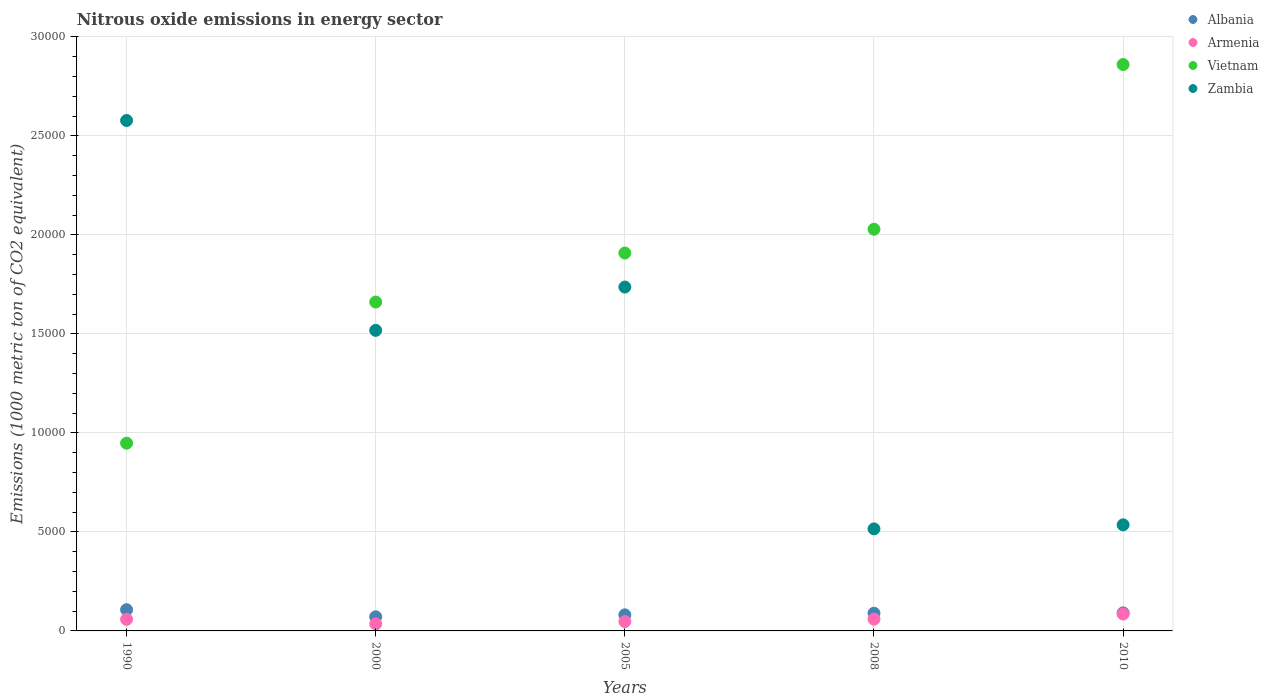How many different coloured dotlines are there?
Your response must be concise. 4. What is the amount of nitrous oxide emitted in Armenia in 2000?
Offer a terse response. 356.1. Across all years, what is the maximum amount of nitrous oxide emitted in Zambia?
Make the answer very short. 2.58e+04. Across all years, what is the minimum amount of nitrous oxide emitted in Vietnam?
Ensure brevity in your answer.  9479.8. What is the total amount of nitrous oxide emitted in Albania in the graph?
Provide a succinct answer. 4401. What is the difference between the amount of nitrous oxide emitted in Zambia in 2000 and that in 2005?
Give a very brief answer. -2187.2. What is the difference between the amount of nitrous oxide emitted in Vietnam in 2005 and the amount of nitrous oxide emitted in Armenia in 2010?
Offer a very short reply. 1.82e+04. What is the average amount of nitrous oxide emitted in Vietnam per year?
Offer a terse response. 1.88e+04. In the year 2000, what is the difference between the amount of nitrous oxide emitted in Zambia and amount of nitrous oxide emitted in Albania?
Your answer should be compact. 1.45e+04. In how many years, is the amount of nitrous oxide emitted in Armenia greater than 7000 1000 metric ton?
Offer a terse response. 0. What is the ratio of the amount of nitrous oxide emitted in Zambia in 2005 to that in 2008?
Offer a terse response. 3.37. Is the amount of nitrous oxide emitted in Zambia in 1990 less than that in 2008?
Give a very brief answer. No. What is the difference between the highest and the second highest amount of nitrous oxide emitted in Armenia?
Provide a short and direct response. 259.9. What is the difference between the highest and the lowest amount of nitrous oxide emitted in Armenia?
Offer a very short reply. 497.3. Is the sum of the amount of nitrous oxide emitted in Albania in 2005 and 2008 greater than the maximum amount of nitrous oxide emitted in Armenia across all years?
Give a very brief answer. Yes. Is it the case that in every year, the sum of the amount of nitrous oxide emitted in Zambia and amount of nitrous oxide emitted in Vietnam  is greater than the amount of nitrous oxide emitted in Armenia?
Provide a short and direct response. Yes. Does the amount of nitrous oxide emitted in Vietnam monotonically increase over the years?
Keep it short and to the point. Yes. Is the amount of nitrous oxide emitted in Zambia strictly less than the amount of nitrous oxide emitted in Albania over the years?
Offer a very short reply. No. What is the difference between two consecutive major ticks on the Y-axis?
Offer a very short reply. 5000. Does the graph contain grids?
Ensure brevity in your answer.  Yes. Where does the legend appear in the graph?
Your answer should be compact. Top right. How many legend labels are there?
Make the answer very short. 4. How are the legend labels stacked?
Keep it short and to the point. Vertical. What is the title of the graph?
Your response must be concise. Nitrous oxide emissions in energy sector. Does "Barbados" appear as one of the legend labels in the graph?
Offer a very short reply. No. What is the label or title of the Y-axis?
Ensure brevity in your answer.  Emissions (1000 metric ton of CO2 equivalent). What is the Emissions (1000 metric ton of CO2 equivalent) in Albania in 1990?
Your answer should be compact. 1071.9. What is the Emissions (1000 metric ton of CO2 equivalent) of Armenia in 1990?
Your answer should be compact. 586.2. What is the Emissions (1000 metric ton of CO2 equivalent) in Vietnam in 1990?
Give a very brief answer. 9479.8. What is the Emissions (1000 metric ton of CO2 equivalent) in Zambia in 1990?
Provide a short and direct response. 2.58e+04. What is the Emissions (1000 metric ton of CO2 equivalent) of Albania in 2000?
Your response must be concise. 712.1. What is the Emissions (1000 metric ton of CO2 equivalent) of Armenia in 2000?
Provide a short and direct response. 356.1. What is the Emissions (1000 metric ton of CO2 equivalent) in Vietnam in 2000?
Offer a very short reply. 1.66e+04. What is the Emissions (1000 metric ton of CO2 equivalent) of Zambia in 2000?
Provide a short and direct response. 1.52e+04. What is the Emissions (1000 metric ton of CO2 equivalent) of Albania in 2005?
Offer a terse response. 812. What is the Emissions (1000 metric ton of CO2 equivalent) of Armenia in 2005?
Make the answer very short. 473.3. What is the Emissions (1000 metric ton of CO2 equivalent) of Vietnam in 2005?
Your answer should be very brief. 1.91e+04. What is the Emissions (1000 metric ton of CO2 equivalent) of Zambia in 2005?
Give a very brief answer. 1.74e+04. What is the Emissions (1000 metric ton of CO2 equivalent) in Albania in 2008?
Your response must be concise. 894. What is the Emissions (1000 metric ton of CO2 equivalent) in Armenia in 2008?
Your response must be concise. 593.5. What is the Emissions (1000 metric ton of CO2 equivalent) of Vietnam in 2008?
Give a very brief answer. 2.03e+04. What is the Emissions (1000 metric ton of CO2 equivalent) of Zambia in 2008?
Offer a terse response. 5152.9. What is the Emissions (1000 metric ton of CO2 equivalent) in Albania in 2010?
Provide a succinct answer. 911. What is the Emissions (1000 metric ton of CO2 equivalent) of Armenia in 2010?
Your answer should be compact. 853.4. What is the Emissions (1000 metric ton of CO2 equivalent) in Vietnam in 2010?
Make the answer very short. 2.86e+04. What is the Emissions (1000 metric ton of CO2 equivalent) in Zambia in 2010?
Provide a short and direct response. 5357.6. Across all years, what is the maximum Emissions (1000 metric ton of CO2 equivalent) in Albania?
Your answer should be compact. 1071.9. Across all years, what is the maximum Emissions (1000 metric ton of CO2 equivalent) in Armenia?
Provide a succinct answer. 853.4. Across all years, what is the maximum Emissions (1000 metric ton of CO2 equivalent) of Vietnam?
Your answer should be very brief. 2.86e+04. Across all years, what is the maximum Emissions (1000 metric ton of CO2 equivalent) of Zambia?
Offer a very short reply. 2.58e+04. Across all years, what is the minimum Emissions (1000 metric ton of CO2 equivalent) of Albania?
Your response must be concise. 712.1. Across all years, what is the minimum Emissions (1000 metric ton of CO2 equivalent) in Armenia?
Provide a succinct answer. 356.1. Across all years, what is the minimum Emissions (1000 metric ton of CO2 equivalent) of Vietnam?
Your response must be concise. 9479.8. Across all years, what is the minimum Emissions (1000 metric ton of CO2 equivalent) of Zambia?
Offer a terse response. 5152.9. What is the total Emissions (1000 metric ton of CO2 equivalent) of Albania in the graph?
Provide a succinct answer. 4401. What is the total Emissions (1000 metric ton of CO2 equivalent) in Armenia in the graph?
Provide a short and direct response. 2862.5. What is the total Emissions (1000 metric ton of CO2 equivalent) in Vietnam in the graph?
Offer a terse response. 9.40e+04. What is the total Emissions (1000 metric ton of CO2 equivalent) of Zambia in the graph?
Provide a succinct answer. 6.88e+04. What is the difference between the Emissions (1000 metric ton of CO2 equivalent) in Albania in 1990 and that in 2000?
Ensure brevity in your answer.  359.8. What is the difference between the Emissions (1000 metric ton of CO2 equivalent) of Armenia in 1990 and that in 2000?
Your response must be concise. 230.1. What is the difference between the Emissions (1000 metric ton of CO2 equivalent) of Vietnam in 1990 and that in 2000?
Keep it short and to the point. -7126.8. What is the difference between the Emissions (1000 metric ton of CO2 equivalent) in Zambia in 1990 and that in 2000?
Provide a short and direct response. 1.06e+04. What is the difference between the Emissions (1000 metric ton of CO2 equivalent) in Albania in 1990 and that in 2005?
Offer a very short reply. 259.9. What is the difference between the Emissions (1000 metric ton of CO2 equivalent) of Armenia in 1990 and that in 2005?
Provide a succinct answer. 112.9. What is the difference between the Emissions (1000 metric ton of CO2 equivalent) in Vietnam in 1990 and that in 2005?
Keep it short and to the point. -9601.2. What is the difference between the Emissions (1000 metric ton of CO2 equivalent) of Zambia in 1990 and that in 2005?
Keep it short and to the point. 8411.4. What is the difference between the Emissions (1000 metric ton of CO2 equivalent) of Albania in 1990 and that in 2008?
Provide a short and direct response. 177.9. What is the difference between the Emissions (1000 metric ton of CO2 equivalent) in Vietnam in 1990 and that in 2008?
Your answer should be very brief. -1.08e+04. What is the difference between the Emissions (1000 metric ton of CO2 equivalent) of Zambia in 1990 and that in 2008?
Your answer should be compact. 2.06e+04. What is the difference between the Emissions (1000 metric ton of CO2 equivalent) in Albania in 1990 and that in 2010?
Keep it short and to the point. 160.9. What is the difference between the Emissions (1000 metric ton of CO2 equivalent) of Armenia in 1990 and that in 2010?
Offer a very short reply. -267.2. What is the difference between the Emissions (1000 metric ton of CO2 equivalent) in Vietnam in 1990 and that in 2010?
Offer a very short reply. -1.91e+04. What is the difference between the Emissions (1000 metric ton of CO2 equivalent) in Zambia in 1990 and that in 2010?
Your answer should be very brief. 2.04e+04. What is the difference between the Emissions (1000 metric ton of CO2 equivalent) of Albania in 2000 and that in 2005?
Provide a short and direct response. -99.9. What is the difference between the Emissions (1000 metric ton of CO2 equivalent) of Armenia in 2000 and that in 2005?
Your response must be concise. -117.2. What is the difference between the Emissions (1000 metric ton of CO2 equivalent) in Vietnam in 2000 and that in 2005?
Offer a terse response. -2474.4. What is the difference between the Emissions (1000 metric ton of CO2 equivalent) of Zambia in 2000 and that in 2005?
Make the answer very short. -2187.2. What is the difference between the Emissions (1000 metric ton of CO2 equivalent) in Albania in 2000 and that in 2008?
Ensure brevity in your answer.  -181.9. What is the difference between the Emissions (1000 metric ton of CO2 equivalent) of Armenia in 2000 and that in 2008?
Offer a very short reply. -237.4. What is the difference between the Emissions (1000 metric ton of CO2 equivalent) of Vietnam in 2000 and that in 2008?
Your response must be concise. -3676.6. What is the difference between the Emissions (1000 metric ton of CO2 equivalent) in Zambia in 2000 and that in 2008?
Offer a terse response. 1.00e+04. What is the difference between the Emissions (1000 metric ton of CO2 equivalent) of Albania in 2000 and that in 2010?
Provide a succinct answer. -198.9. What is the difference between the Emissions (1000 metric ton of CO2 equivalent) in Armenia in 2000 and that in 2010?
Offer a terse response. -497.3. What is the difference between the Emissions (1000 metric ton of CO2 equivalent) in Vietnam in 2000 and that in 2010?
Make the answer very short. -1.20e+04. What is the difference between the Emissions (1000 metric ton of CO2 equivalent) in Zambia in 2000 and that in 2010?
Offer a terse response. 9818.5. What is the difference between the Emissions (1000 metric ton of CO2 equivalent) in Albania in 2005 and that in 2008?
Your response must be concise. -82. What is the difference between the Emissions (1000 metric ton of CO2 equivalent) of Armenia in 2005 and that in 2008?
Provide a succinct answer. -120.2. What is the difference between the Emissions (1000 metric ton of CO2 equivalent) in Vietnam in 2005 and that in 2008?
Offer a terse response. -1202.2. What is the difference between the Emissions (1000 metric ton of CO2 equivalent) of Zambia in 2005 and that in 2008?
Keep it short and to the point. 1.22e+04. What is the difference between the Emissions (1000 metric ton of CO2 equivalent) in Albania in 2005 and that in 2010?
Provide a short and direct response. -99. What is the difference between the Emissions (1000 metric ton of CO2 equivalent) in Armenia in 2005 and that in 2010?
Provide a short and direct response. -380.1. What is the difference between the Emissions (1000 metric ton of CO2 equivalent) of Vietnam in 2005 and that in 2010?
Give a very brief answer. -9517.8. What is the difference between the Emissions (1000 metric ton of CO2 equivalent) in Zambia in 2005 and that in 2010?
Your response must be concise. 1.20e+04. What is the difference between the Emissions (1000 metric ton of CO2 equivalent) of Armenia in 2008 and that in 2010?
Ensure brevity in your answer.  -259.9. What is the difference between the Emissions (1000 metric ton of CO2 equivalent) of Vietnam in 2008 and that in 2010?
Your response must be concise. -8315.6. What is the difference between the Emissions (1000 metric ton of CO2 equivalent) of Zambia in 2008 and that in 2010?
Offer a terse response. -204.7. What is the difference between the Emissions (1000 metric ton of CO2 equivalent) in Albania in 1990 and the Emissions (1000 metric ton of CO2 equivalent) in Armenia in 2000?
Provide a short and direct response. 715.8. What is the difference between the Emissions (1000 metric ton of CO2 equivalent) in Albania in 1990 and the Emissions (1000 metric ton of CO2 equivalent) in Vietnam in 2000?
Ensure brevity in your answer.  -1.55e+04. What is the difference between the Emissions (1000 metric ton of CO2 equivalent) of Albania in 1990 and the Emissions (1000 metric ton of CO2 equivalent) of Zambia in 2000?
Your response must be concise. -1.41e+04. What is the difference between the Emissions (1000 metric ton of CO2 equivalent) in Armenia in 1990 and the Emissions (1000 metric ton of CO2 equivalent) in Vietnam in 2000?
Make the answer very short. -1.60e+04. What is the difference between the Emissions (1000 metric ton of CO2 equivalent) in Armenia in 1990 and the Emissions (1000 metric ton of CO2 equivalent) in Zambia in 2000?
Your answer should be compact. -1.46e+04. What is the difference between the Emissions (1000 metric ton of CO2 equivalent) of Vietnam in 1990 and the Emissions (1000 metric ton of CO2 equivalent) of Zambia in 2000?
Offer a terse response. -5696.3. What is the difference between the Emissions (1000 metric ton of CO2 equivalent) in Albania in 1990 and the Emissions (1000 metric ton of CO2 equivalent) in Armenia in 2005?
Offer a very short reply. 598.6. What is the difference between the Emissions (1000 metric ton of CO2 equivalent) in Albania in 1990 and the Emissions (1000 metric ton of CO2 equivalent) in Vietnam in 2005?
Keep it short and to the point. -1.80e+04. What is the difference between the Emissions (1000 metric ton of CO2 equivalent) in Albania in 1990 and the Emissions (1000 metric ton of CO2 equivalent) in Zambia in 2005?
Ensure brevity in your answer.  -1.63e+04. What is the difference between the Emissions (1000 metric ton of CO2 equivalent) in Armenia in 1990 and the Emissions (1000 metric ton of CO2 equivalent) in Vietnam in 2005?
Provide a succinct answer. -1.85e+04. What is the difference between the Emissions (1000 metric ton of CO2 equivalent) in Armenia in 1990 and the Emissions (1000 metric ton of CO2 equivalent) in Zambia in 2005?
Ensure brevity in your answer.  -1.68e+04. What is the difference between the Emissions (1000 metric ton of CO2 equivalent) of Vietnam in 1990 and the Emissions (1000 metric ton of CO2 equivalent) of Zambia in 2005?
Your answer should be compact. -7883.5. What is the difference between the Emissions (1000 metric ton of CO2 equivalent) of Albania in 1990 and the Emissions (1000 metric ton of CO2 equivalent) of Armenia in 2008?
Your answer should be compact. 478.4. What is the difference between the Emissions (1000 metric ton of CO2 equivalent) in Albania in 1990 and the Emissions (1000 metric ton of CO2 equivalent) in Vietnam in 2008?
Offer a terse response. -1.92e+04. What is the difference between the Emissions (1000 metric ton of CO2 equivalent) of Albania in 1990 and the Emissions (1000 metric ton of CO2 equivalent) of Zambia in 2008?
Make the answer very short. -4081. What is the difference between the Emissions (1000 metric ton of CO2 equivalent) in Armenia in 1990 and the Emissions (1000 metric ton of CO2 equivalent) in Vietnam in 2008?
Offer a terse response. -1.97e+04. What is the difference between the Emissions (1000 metric ton of CO2 equivalent) in Armenia in 1990 and the Emissions (1000 metric ton of CO2 equivalent) in Zambia in 2008?
Offer a very short reply. -4566.7. What is the difference between the Emissions (1000 metric ton of CO2 equivalent) of Vietnam in 1990 and the Emissions (1000 metric ton of CO2 equivalent) of Zambia in 2008?
Keep it short and to the point. 4326.9. What is the difference between the Emissions (1000 metric ton of CO2 equivalent) of Albania in 1990 and the Emissions (1000 metric ton of CO2 equivalent) of Armenia in 2010?
Provide a succinct answer. 218.5. What is the difference between the Emissions (1000 metric ton of CO2 equivalent) of Albania in 1990 and the Emissions (1000 metric ton of CO2 equivalent) of Vietnam in 2010?
Your response must be concise. -2.75e+04. What is the difference between the Emissions (1000 metric ton of CO2 equivalent) in Albania in 1990 and the Emissions (1000 metric ton of CO2 equivalent) in Zambia in 2010?
Ensure brevity in your answer.  -4285.7. What is the difference between the Emissions (1000 metric ton of CO2 equivalent) of Armenia in 1990 and the Emissions (1000 metric ton of CO2 equivalent) of Vietnam in 2010?
Your answer should be very brief. -2.80e+04. What is the difference between the Emissions (1000 metric ton of CO2 equivalent) in Armenia in 1990 and the Emissions (1000 metric ton of CO2 equivalent) in Zambia in 2010?
Make the answer very short. -4771.4. What is the difference between the Emissions (1000 metric ton of CO2 equivalent) of Vietnam in 1990 and the Emissions (1000 metric ton of CO2 equivalent) of Zambia in 2010?
Your answer should be very brief. 4122.2. What is the difference between the Emissions (1000 metric ton of CO2 equivalent) of Albania in 2000 and the Emissions (1000 metric ton of CO2 equivalent) of Armenia in 2005?
Keep it short and to the point. 238.8. What is the difference between the Emissions (1000 metric ton of CO2 equivalent) in Albania in 2000 and the Emissions (1000 metric ton of CO2 equivalent) in Vietnam in 2005?
Ensure brevity in your answer.  -1.84e+04. What is the difference between the Emissions (1000 metric ton of CO2 equivalent) in Albania in 2000 and the Emissions (1000 metric ton of CO2 equivalent) in Zambia in 2005?
Offer a very short reply. -1.67e+04. What is the difference between the Emissions (1000 metric ton of CO2 equivalent) in Armenia in 2000 and the Emissions (1000 metric ton of CO2 equivalent) in Vietnam in 2005?
Make the answer very short. -1.87e+04. What is the difference between the Emissions (1000 metric ton of CO2 equivalent) in Armenia in 2000 and the Emissions (1000 metric ton of CO2 equivalent) in Zambia in 2005?
Your answer should be compact. -1.70e+04. What is the difference between the Emissions (1000 metric ton of CO2 equivalent) in Vietnam in 2000 and the Emissions (1000 metric ton of CO2 equivalent) in Zambia in 2005?
Provide a succinct answer. -756.7. What is the difference between the Emissions (1000 metric ton of CO2 equivalent) of Albania in 2000 and the Emissions (1000 metric ton of CO2 equivalent) of Armenia in 2008?
Provide a short and direct response. 118.6. What is the difference between the Emissions (1000 metric ton of CO2 equivalent) of Albania in 2000 and the Emissions (1000 metric ton of CO2 equivalent) of Vietnam in 2008?
Your answer should be very brief. -1.96e+04. What is the difference between the Emissions (1000 metric ton of CO2 equivalent) in Albania in 2000 and the Emissions (1000 metric ton of CO2 equivalent) in Zambia in 2008?
Make the answer very short. -4440.8. What is the difference between the Emissions (1000 metric ton of CO2 equivalent) in Armenia in 2000 and the Emissions (1000 metric ton of CO2 equivalent) in Vietnam in 2008?
Offer a very short reply. -1.99e+04. What is the difference between the Emissions (1000 metric ton of CO2 equivalent) of Armenia in 2000 and the Emissions (1000 metric ton of CO2 equivalent) of Zambia in 2008?
Your answer should be compact. -4796.8. What is the difference between the Emissions (1000 metric ton of CO2 equivalent) of Vietnam in 2000 and the Emissions (1000 metric ton of CO2 equivalent) of Zambia in 2008?
Give a very brief answer. 1.15e+04. What is the difference between the Emissions (1000 metric ton of CO2 equivalent) in Albania in 2000 and the Emissions (1000 metric ton of CO2 equivalent) in Armenia in 2010?
Offer a terse response. -141.3. What is the difference between the Emissions (1000 metric ton of CO2 equivalent) of Albania in 2000 and the Emissions (1000 metric ton of CO2 equivalent) of Vietnam in 2010?
Give a very brief answer. -2.79e+04. What is the difference between the Emissions (1000 metric ton of CO2 equivalent) in Albania in 2000 and the Emissions (1000 metric ton of CO2 equivalent) in Zambia in 2010?
Your response must be concise. -4645.5. What is the difference between the Emissions (1000 metric ton of CO2 equivalent) in Armenia in 2000 and the Emissions (1000 metric ton of CO2 equivalent) in Vietnam in 2010?
Offer a very short reply. -2.82e+04. What is the difference between the Emissions (1000 metric ton of CO2 equivalent) in Armenia in 2000 and the Emissions (1000 metric ton of CO2 equivalent) in Zambia in 2010?
Make the answer very short. -5001.5. What is the difference between the Emissions (1000 metric ton of CO2 equivalent) in Vietnam in 2000 and the Emissions (1000 metric ton of CO2 equivalent) in Zambia in 2010?
Provide a short and direct response. 1.12e+04. What is the difference between the Emissions (1000 metric ton of CO2 equivalent) in Albania in 2005 and the Emissions (1000 metric ton of CO2 equivalent) in Armenia in 2008?
Give a very brief answer. 218.5. What is the difference between the Emissions (1000 metric ton of CO2 equivalent) in Albania in 2005 and the Emissions (1000 metric ton of CO2 equivalent) in Vietnam in 2008?
Your answer should be compact. -1.95e+04. What is the difference between the Emissions (1000 metric ton of CO2 equivalent) in Albania in 2005 and the Emissions (1000 metric ton of CO2 equivalent) in Zambia in 2008?
Your answer should be very brief. -4340.9. What is the difference between the Emissions (1000 metric ton of CO2 equivalent) of Armenia in 2005 and the Emissions (1000 metric ton of CO2 equivalent) of Vietnam in 2008?
Your answer should be very brief. -1.98e+04. What is the difference between the Emissions (1000 metric ton of CO2 equivalent) of Armenia in 2005 and the Emissions (1000 metric ton of CO2 equivalent) of Zambia in 2008?
Your answer should be compact. -4679.6. What is the difference between the Emissions (1000 metric ton of CO2 equivalent) of Vietnam in 2005 and the Emissions (1000 metric ton of CO2 equivalent) of Zambia in 2008?
Make the answer very short. 1.39e+04. What is the difference between the Emissions (1000 metric ton of CO2 equivalent) of Albania in 2005 and the Emissions (1000 metric ton of CO2 equivalent) of Armenia in 2010?
Offer a very short reply. -41.4. What is the difference between the Emissions (1000 metric ton of CO2 equivalent) in Albania in 2005 and the Emissions (1000 metric ton of CO2 equivalent) in Vietnam in 2010?
Provide a succinct answer. -2.78e+04. What is the difference between the Emissions (1000 metric ton of CO2 equivalent) in Albania in 2005 and the Emissions (1000 metric ton of CO2 equivalent) in Zambia in 2010?
Offer a very short reply. -4545.6. What is the difference between the Emissions (1000 metric ton of CO2 equivalent) in Armenia in 2005 and the Emissions (1000 metric ton of CO2 equivalent) in Vietnam in 2010?
Keep it short and to the point. -2.81e+04. What is the difference between the Emissions (1000 metric ton of CO2 equivalent) in Armenia in 2005 and the Emissions (1000 metric ton of CO2 equivalent) in Zambia in 2010?
Keep it short and to the point. -4884.3. What is the difference between the Emissions (1000 metric ton of CO2 equivalent) in Vietnam in 2005 and the Emissions (1000 metric ton of CO2 equivalent) in Zambia in 2010?
Your answer should be very brief. 1.37e+04. What is the difference between the Emissions (1000 metric ton of CO2 equivalent) of Albania in 2008 and the Emissions (1000 metric ton of CO2 equivalent) of Armenia in 2010?
Keep it short and to the point. 40.6. What is the difference between the Emissions (1000 metric ton of CO2 equivalent) of Albania in 2008 and the Emissions (1000 metric ton of CO2 equivalent) of Vietnam in 2010?
Give a very brief answer. -2.77e+04. What is the difference between the Emissions (1000 metric ton of CO2 equivalent) of Albania in 2008 and the Emissions (1000 metric ton of CO2 equivalent) of Zambia in 2010?
Offer a terse response. -4463.6. What is the difference between the Emissions (1000 metric ton of CO2 equivalent) in Armenia in 2008 and the Emissions (1000 metric ton of CO2 equivalent) in Vietnam in 2010?
Offer a terse response. -2.80e+04. What is the difference between the Emissions (1000 metric ton of CO2 equivalent) of Armenia in 2008 and the Emissions (1000 metric ton of CO2 equivalent) of Zambia in 2010?
Provide a succinct answer. -4764.1. What is the difference between the Emissions (1000 metric ton of CO2 equivalent) of Vietnam in 2008 and the Emissions (1000 metric ton of CO2 equivalent) of Zambia in 2010?
Offer a very short reply. 1.49e+04. What is the average Emissions (1000 metric ton of CO2 equivalent) of Albania per year?
Provide a short and direct response. 880.2. What is the average Emissions (1000 metric ton of CO2 equivalent) of Armenia per year?
Your answer should be compact. 572.5. What is the average Emissions (1000 metric ton of CO2 equivalent) of Vietnam per year?
Your answer should be compact. 1.88e+04. What is the average Emissions (1000 metric ton of CO2 equivalent) of Zambia per year?
Offer a very short reply. 1.38e+04. In the year 1990, what is the difference between the Emissions (1000 metric ton of CO2 equivalent) in Albania and Emissions (1000 metric ton of CO2 equivalent) in Armenia?
Your response must be concise. 485.7. In the year 1990, what is the difference between the Emissions (1000 metric ton of CO2 equivalent) in Albania and Emissions (1000 metric ton of CO2 equivalent) in Vietnam?
Provide a succinct answer. -8407.9. In the year 1990, what is the difference between the Emissions (1000 metric ton of CO2 equivalent) of Albania and Emissions (1000 metric ton of CO2 equivalent) of Zambia?
Offer a terse response. -2.47e+04. In the year 1990, what is the difference between the Emissions (1000 metric ton of CO2 equivalent) of Armenia and Emissions (1000 metric ton of CO2 equivalent) of Vietnam?
Provide a short and direct response. -8893.6. In the year 1990, what is the difference between the Emissions (1000 metric ton of CO2 equivalent) of Armenia and Emissions (1000 metric ton of CO2 equivalent) of Zambia?
Provide a short and direct response. -2.52e+04. In the year 1990, what is the difference between the Emissions (1000 metric ton of CO2 equivalent) of Vietnam and Emissions (1000 metric ton of CO2 equivalent) of Zambia?
Provide a short and direct response. -1.63e+04. In the year 2000, what is the difference between the Emissions (1000 metric ton of CO2 equivalent) of Albania and Emissions (1000 metric ton of CO2 equivalent) of Armenia?
Make the answer very short. 356. In the year 2000, what is the difference between the Emissions (1000 metric ton of CO2 equivalent) in Albania and Emissions (1000 metric ton of CO2 equivalent) in Vietnam?
Keep it short and to the point. -1.59e+04. In the year 2000, what is the difference between the Emissions (1000 metric ton of CO2 equivalent) of Albania and Emissions (1000 metric ton of CO2 equivalent) of Zambia?
Provide a short and direct response. -1.45e+04. In the year 2000, what is the difference between the Emissions (1000 metric ton of CO2 equivalent) of Armenia and Emissions (1000 metric ton of CO2 equivalent) of Vietnam?
Your answer should be compact. -1.63e+04. In the year 2000, what is the difference between the Emissions (1000 metric ton of CO2 equivalent) of Armenia and Emissions (1000 metric ton of CO2 equivalent) of Zambia?
Make the answer very short. -1.48e+04. In the year 2000, what is the difference between the Emissions (1000 metric ton of CO2 equivalent) of Vietnam and Emissions (1000 metric ton of CO2 equivalent) of Zambia?
Your response must be concise. 1430.5. In the year 2005, what is the difference between the Emissions (1000 metric ton of CO2 equivalent) in Albania and Emissions (1000 metric ton of CO2 equivalent) in Armenia?
Provide a short and direct response. 338.7. In the year 2005, what is the difference between the Emissions (1000 metric ton of CO2 equivalent) in Albania and Emissions (1000 metric ton of CO2 equivalent) in Vietnam?
Your answer should be compact. -1.83e+04. In the year 2005, what is the difference between the Emissions (1000 metric ton of CO2 equivalent) of Albania and Emissions (1000 metric ton of CO2 equivalent) of Zambia?
Give a very brief answer. -1.66e+04. In the year 2005, what is the difference between the Emissions (1000 metric ton of CO2 equivalent) in Armenia and Emissions (1000 metric ton of CO2 equivalent) in Vietnam?
Provide a succinct answer. -1.86e+04. In the year 2005, what is the difference between the Emissions (1000 metric ton of CO2 equivalent) of Armenia and Emissions (1000 metric ton of CO2 equivalent) of Zambia?
Your answer should be very brief. -1.69e+04. In the year 2005, what is the difference between the Emissions (1000 metric ton of CO2 equivalent) of Vietnam and Emissions (1000 metric ton of CO2 equivalent) of Zambia?
Keep it short and to the point. 1717.7. In the year 2008, what is the difference between the Emissions (1000 metric ton of CO2 equivalent) of Albania and Emissions (1000 metric ton of CO2 equivalent) of Armenia?
Your response must be concise. 300.5. In the year 2008, what is the difference between the Emissions (1000 metric ton of CO2 equivalent) in Albania and Emissions (1000 metric ton of CO2 equivalent) in Vietnam?
Your answer should be compact. -1.94e+04. In the year 2008, what is the difference between the Emissions (1000 metric ton of CO2 equivalent) of Albania and Emissions (1000 metric ton of CO2 equivalent) of Zambia?
Offer a very short reply. -4258.9. In the year 2008, what is the difference between the Emissions (1000 metric ton of CO2 equivalent) of Armenia and Emissions (1000 metric ton of CO2 equivalent) of Vietnam?
Your response must be concise. -1.97e+04. In the year 2008, what is the difference between the Emissions (1000 metric ton of CO2 equivalent) in Armenia and Emissions (1000 metric ton of CO2 equivalent) in Zambia?
Offer a terse response. -4559.4. In the year 2008, what is the difference between the Emissions (1000 metric ton of CO2 equivalent) in Vietnam and Emissions (1000 metric ton of CO2 equivalent) in Zambia?
Offer a very short reply. 1.51e+04. In the year 2010, what is the difference between the Emissions (1000 metric ton of CO2 equivalent) in Albania and Emissions (1000 metric ton of CO2 equivalent) in Armenia?
Provide a short and direct response. 57.6. In the year 2010, what is the difference between the Emissions (1000 metric ton of CO2 equivalent) in Albania and Emissions (1000 metric ton of CO2 equivalent) in Vietnam?
Keep it short and to the point. -2.77e+04. In the year 2010, what is the difference between the Emissions (1000 metric ton of CO2 equivalent) in Albania and Emissions (1000 metric ton of CO2 equivalent) in Zambia?
Ensure brevity in your answer.  -4446.6. In the year 2010, what is the difference between the Emissions (1000 metric ton of CO2 equivalent) in Armenia and Emissions (1000 metric ton of CO2 equivalent) in Vietnam?
Give a very brief answer. -2.77e+04. In the year 2010, what is the difference between the Emissions (1000 metric ton of CO2 equivalent) of Armenia and Emissions (1000 metric ton of CO2 equivalent) of Zambia?
Make the answer very short. -4504.2. In the year 2010, what is the difference between the Emissions (1000 metric ton of CO2 equivalent) in Vietnam and Emissions (1000 metric ton of CO2 equivalent) in Zambia?
Your response must be concise. 2.32e+04. What is the ratio of the Emissions (1000 metric ton of CO2 equivalent) of Albania in 1990 to that in 2000?
Make the answer very short. 1.51. What is the ratio of the Emissions (1000 metric ton of CO2 equivalent) of Armenia in 1990 to that in 2000?
Keep it short and to the point. 1.65. What is the ratio of the Emissions (1000 metric ton of CO2 equivalent) in Vietnam in 1990 to that in 2000?
Keep it short and to the point. 0.57. What is the ratio of the Emissions (1000 metric ton of CO2 equivalent) of Zambia in 1990 to that in 2000?
Keep it short and to the point. 1.7. What is the ratio of the Emissions (1000 metric ton of CO2 equivalent) in Albania in 1990 to that in 2005?
Make the answer very short. 1.32. What is the ratio of the Emissions (1000 metric ton of CO2 equivalent) of Armenia in 1990 to that in 2005?
Provide a short and direct response. 1.24. What is the ratio of the Emissions (1000 metric ton of CO2 equivalent) of Vietnam in 1990 to that in 2005?
Your answer should be compact. 0.5. What is the ratio of the Emissions (1000 metric ton of CO2 equivalent) of Zambia in 1990 to that in 2005?
Your answer should be very brief. 1.48. What is the ratio of the Emissions (1000 metric ton of CO2 equivalent) of Albania in 1990 to that in 2008?
Provide a succinct answer. 1.2. What is the ratio of the Emissions (1000 metric ton of CO2 equivalent) in Armenia in 1990 to that in 2008?
Make the answer very short. 0.99. What is the ratio of the Emissions (1000 metric ton of CO2 equivalent) in Vietnam in 1990 to that in 2008?
Keep it short and to the point. 0.47. What is the ratio of the Emissions (1000 metric ton of CO2 equivalent) of Zambia in 1990 to that in 2008?
Keep it short and to the point. 5. What is the ratio of the Emissions (1000 metric ton of CO2 equivalent) in Albania in 1990 to that in 2010?
Provide a succinct answer. 1.18. What is the ratio of the Emissions (1000 metric ton of CO2 equivalent) in Armenia in 1990 to that in 2010?
Your response must be concise. 0.69. What is the ratio of the Emissions (1000 metric ton of CO2 equivalent) in Vietnam in 1990 to that in 2010?
Offer a terse response. 0.33. What is the ratio of the Emissions (1000 metric ton of CO2 equivalent) of Zambia in 1990 to that in 2010?
Offer a terse response. 4.81. What is the ratio of the Emissions (1000 metric ton of CO2 equivalent) in Albania in 2000 to that in 2005?
Your answer should be compact. 0.88. What is the ratio of the Emissions (1000 metric ton of CO2 equivalent) of Armenia in 2000 to that in 2005?
Give a very brief answer. 0.75. What is the ratio of the Emissions (1000 metric ton of CO2 equivalent) in Vietnam in 2000 to that in 2005?
Ensure brevity in your answer.  0.87. What is the ratio of the Emissions (1000 metric ton of CO2 equivalent) of Zambia in 2000 to that in 2005?
Give a very brief answer. 0.87. What is the ratio of the Emissions (1000 metric ton of CO2 equivalent) of Albania in 2000 to that in 2008?
Your answer should be compact. 0.8. What is the ratio of the Emissions (1000 metric ton of CO2 equivalent) of Armenia in 2000 to that in 2008?
Provide a short and direct response. 0.6. What is the ratio of the Emissions (1000 metric ton of CO2 equivalent) in Vietnam in 2000 to that in 2008?
Give a very brief answer. 0.82. What is the ratio of the Emissions (1000 metric ton of CO2 equivalent) in Zambia in 2000 to that in 2008?
Your response must be concise. 2.95. What is the ratio of the Emissions (1000 metric ton of CO2 equivalent) in Albania in 2000 to that in 2010?
Offer a very short reply. 0.78. What is the ratio of the Emissions (1000 metric ton of CO2 equivalent) of Armenia in 2000 to that in 2010?
Provide a succinct answer. 0.42. What is the ratio of the Emissions (1000 metric ton of CO2 equivalent) of Vietnam in 2000 to that in 2010?
Give a very brief answer. 0.58. What is the ratio of the Emissions (1000 metric ton of CO2 equivalent) in Zambia in 2000 to that in 2010?
Provide a short and direct response. 2.83. What is the ratio of the Emissions (1000 metric ton of CO2 equivalent) in Albania in 2005 to that in 2008?
Provide a succinct answer. 0.91. What is the ratio of the Emissions (1000 metric ton of CO2 equivalent) of Armenia in 2005 to that in 2008?
Provide a succinct answer. 0.8. What is the ratio of the Emissions (1000 metric ton of CO2 equivalent) of Vietnam in 2005 to that in 2008?
Keep it short and to the point. 0.94. What is the ratio of the Emissions (1000 metric ton of CO2 equivalent) in Zambia in 2005 to that in 2008?
Keep it short and to the point. 3.37. What is the ratio of the Emissions (1000 metric ton of CO2 equivalent) in Albania in 2005 to that in 2010?
Offer a very short reply. 0.89. What is the ratio of the Emissions (1000 metric ton of CO2 equivalent) of Armenia in 2005 to that in 2010?
Ensure brevity in your answer.  0.55. What is the ratio of the Emissions (1000 metric ton of CO2 equivalent) in Vietnam in 2005 to that in 2010?
Ensure brevity in your answer.  0.67. What is the ratio of the Emissions (1000 metric ton of CO2 equivalent) of Zambia in 2005 to that in 2010?
Your response must be concise. 3.24. What is the ratio of the Emissions (1000 metric ton of CO2 equivalent) of Albania in 2008 to that in 2010?
Provide a succinct answer. 0.98. What is the ratio of the Emissions (1000 metric ton of CO2 equivalent) of Armenia in 2008 to that in 2010?
Your answer should be very brief. 0.7. What is the ratio of the Emissions (1000 metric ton of CO2 equivalent) in Vietnam in 2008 to that in 2010?
Give a very brief answer. 0.71. What is the ratio of the Emissions (1000 metric ton of CO2 equivalent) in Zambia in 2008 to that in 2010?
Your answer should be compact. 0.96. What is the difference between the highest and the second highest Emissions (1000 metric ton of CO2 equivalent) of Albania?
Your answer should be very brief. 160.9. What is the difference between the highest and the second highest Emissions (1000 metric ton of CO2 equivalent) in Armenia?
Provide a short and direct response. 259.9. What is the difference between the highest and the second highest Emissions (1000 metric ton of CO2 equivalent) in Vietnam?
Make the answer very short. 8315.6. What is the difference between the highest and the second highest Emissions (1000 metric ton of CO2 equivalent) in Zambia?
Ensure brevity in your answer.  8411.4. What is the difference between the highest and the lowest Emissions (1000 metric ton of CO2 equivalent) of Albania?
Your answer should be compact. 359.8. What is the difference between the highest and the lowest Emissions (1000 metric ton of CO2 equivalent) in Armenia?
Your answer should be compact. 497.3. What is the difference between the highest and the lowest Emissions (1000 metric ton of CO2 equivalent) in Vietnam?
Provide a short and direct response. 1.91e+04. What is the difference between the highest and the lowest Emissions (1000 metric ton of CO2 equivalent) in Zambia?
Offer a very short reply. 2.06e+04. 